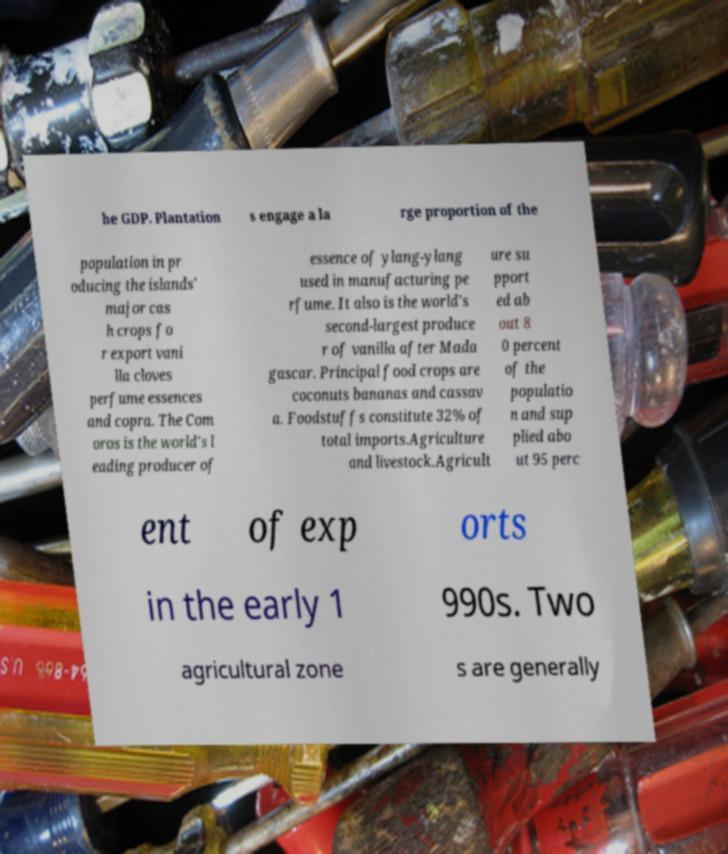Please identify and transcribe the text found in this image. he GDP. Plantation s engage a la rge proportion of the population in pr oducing the islands' major cas h crops fo r export vani lla cloves perfume essences and copra. The Com oros is the world's l eading producer of essence of ylang-ylang used in manufacturing pe rfume. It also is the world's second-largest produce r of vanilla after Mada gascar. Principal food crops are coconuts bananas and cassav a. Foodstuffs constitute 32% of total imports.Agriculture and livestock.Agricult ure su pport ed ab out 8 0 percent of the populatio n and sup plied abo ut 95 perc ent of exp orts in the early 1 990s. Two agricultural zone s are generally 